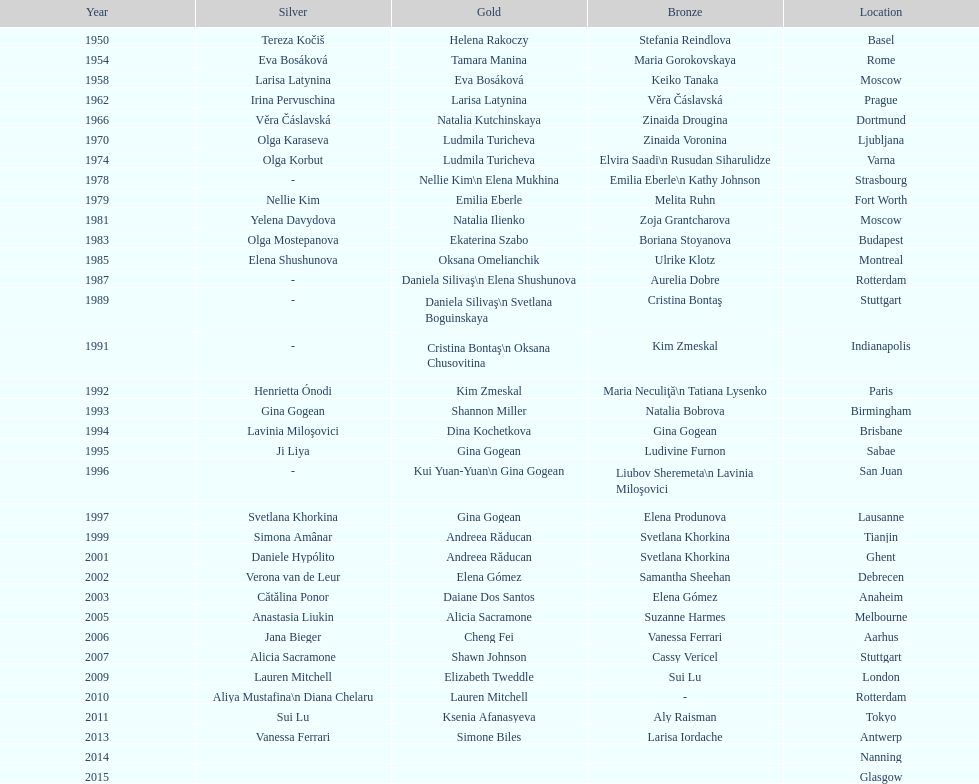How many times was the world artistic gymnastics championships held in the united states? 3. 